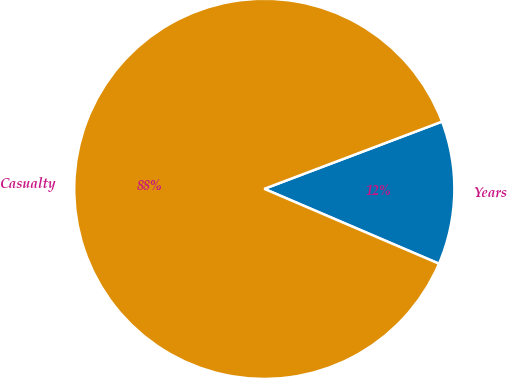Convert chart. <chart><loc_0><loc_0><loc_500><loc_500><pie_chart><fcel>Years<fcel>Casualty<nl><fcel>12.2%<fcel>87.8%<nl></chart> 